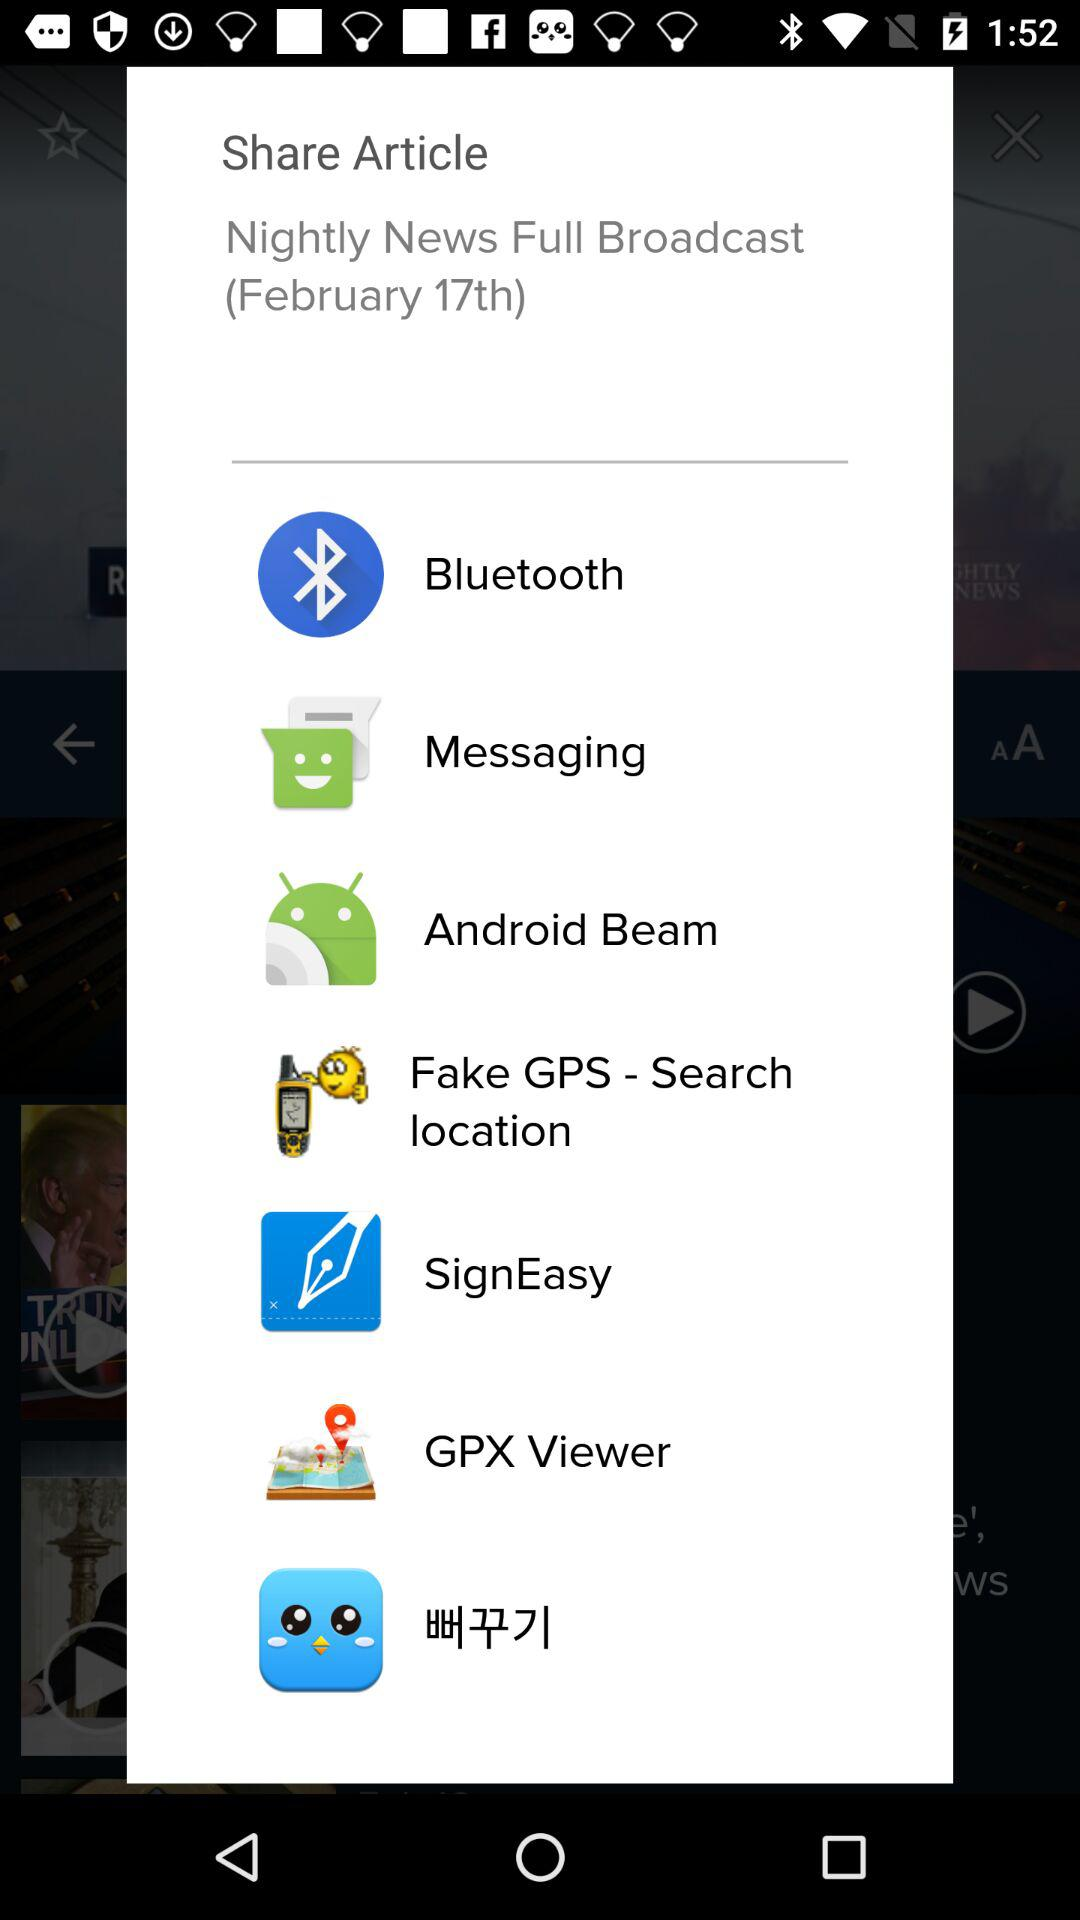What's the published date of the article? The published date of the article is February 17. 